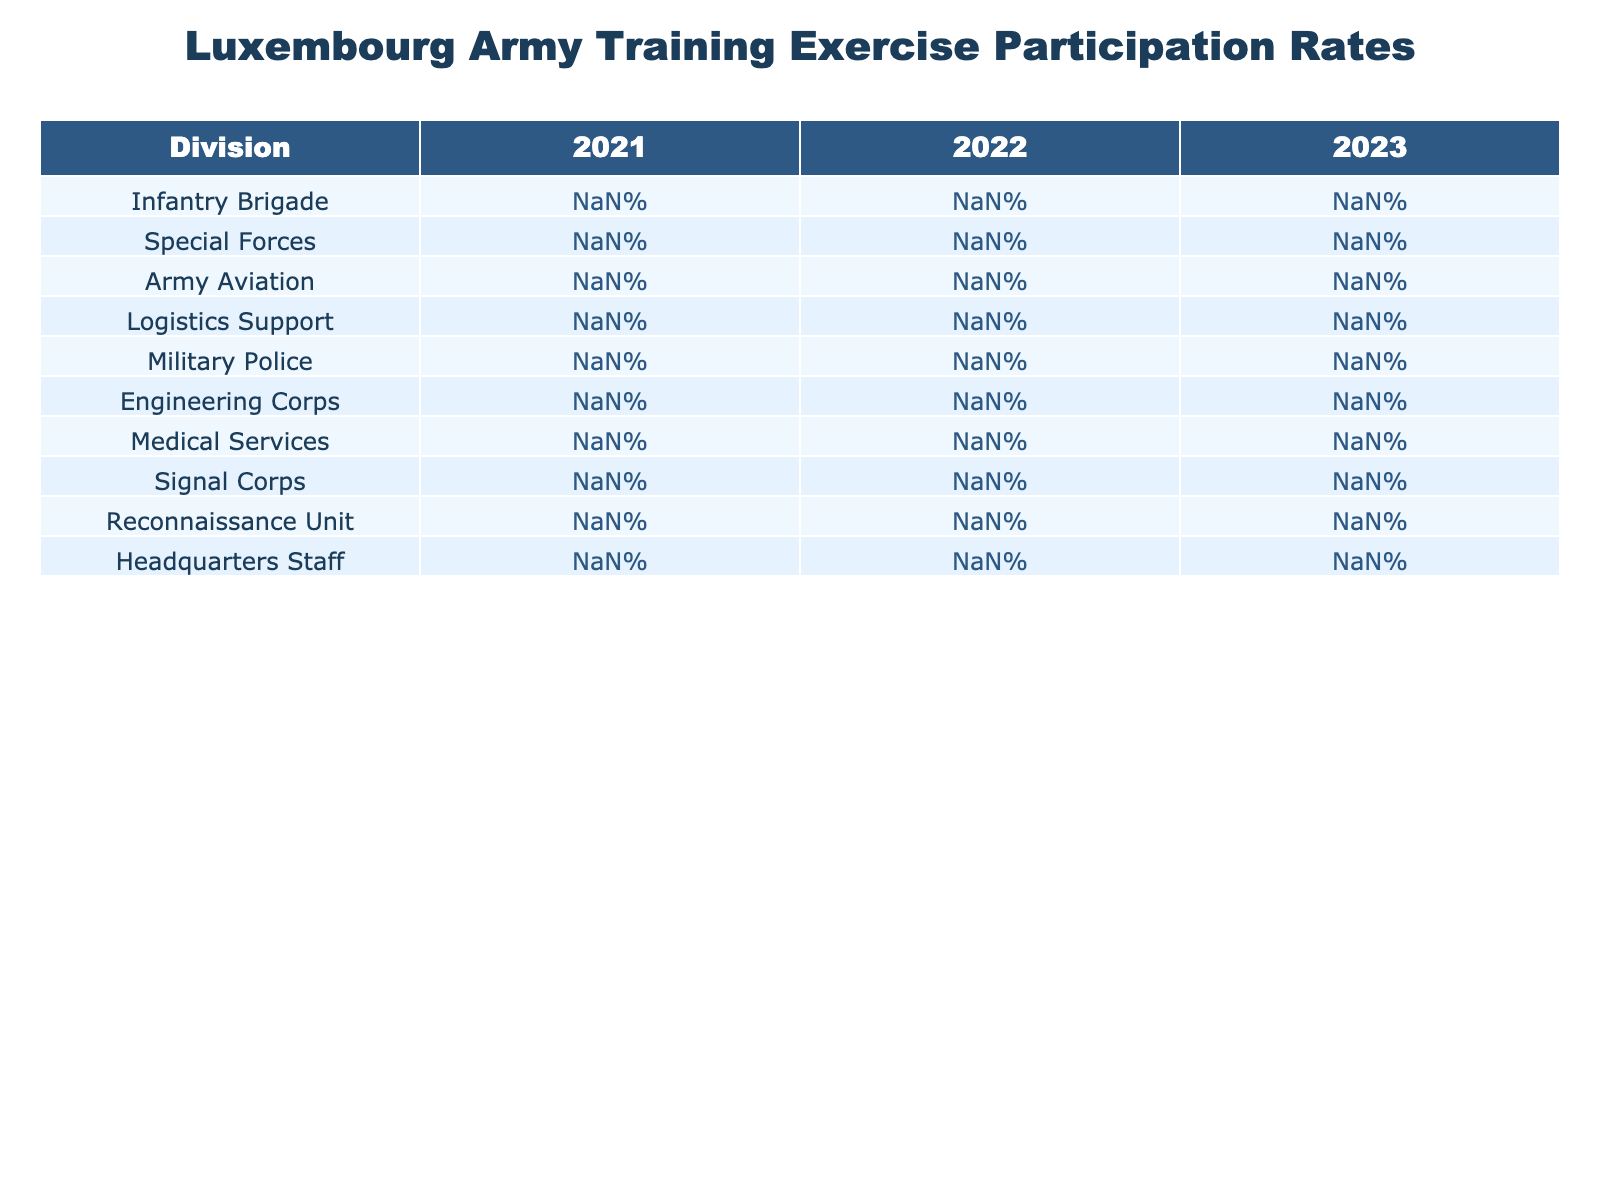What was the participation rate of the Special Forces in 2023? The participation rate for the Special Forces in 2023 is clearly listed in the table under the corresponding year, which shows a rate of 99%.
Answer: 99% Which division had the lowest participation rate in 2021? Looking at the participation rates for the year 2021, the Logistics Support division has the lowest rate at 79%.
Answer: Logistics Support What is the average participation rate across all divisions for 2022? To find the average for 2022, add the participation rates for all divisions: (89 + 97 + 88 + 83 + 93 + 90 + 85 + 91 + 96 + 79) = 90.8%. Then divide by 10 divisions, resulting in an average of 90.8%.
Answer: 90.8% Did the Army Aviation division improve in participation rate from 2021 to 2023? The Army Aviation division had 85% in 2021 and increased to 91% in 2023, indicating an improvement over the two years.
Answer: Yes Which division shows the greatest increase in participation rate from 2021 to 2023? By comparing the rates, the Logistics Support division increased from 79% in 2021 to 87% in 2023. This is the largest increase of 8 percentage points.
Answer: Logistics Support What was the difference in participation rate between the Infantry Brigade and the Headquarters Staff in 2022? In 2022, the Infantry Brigade had a rate of 89% while the Headquarters Staff had 79%. The difference is calculated as 89% - 79% = 10%.
Answer: 10% Is the participation rate of the Medical Services division consistent over the three years? The participation rates for Medical Services were 82% in 2021, 85% in 2022, and 88% in 2023. Since these rates are steadily increasing, we can say it shows consistency in upward growth.
Answer: Yes Which division had the highest participation rate in 2021? Reviewing the table, the Special Forces division had the highest rate in 2021, at 98%.
Answer: Special Forces If you combine the participation rates of the Infantry Brigade and Engineering Corps for 2023, what do you get? The Infantry Brigade had 94% and the Engineering Corps had 92% in 2023. The combined participation is 94% + 92% = 186%.
Answer: 186% What is the trend in participation rates from 2021 to 2023 for the Military Police division? The Military Police saw an increase from 91% in 2021 to 93% in 2022 and then 95% in 2023, indicating a consistent upward trend.
Answer: Increase 